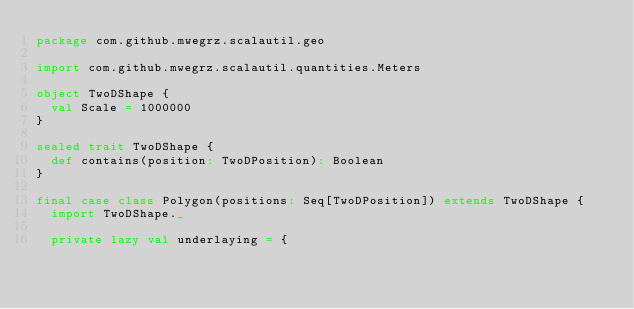Convert code to text. <code><loc_0><loc_0><loc_500><loc_500><_Scala_>package com.github.mwegrz.scalautil.geo

import com.github.mwegrz.scalautil.quantities.Meters

object TwoDShape {
  val Scale = 1000000
}

sealed trait TwoDShape {
  def contains(position: TwoDPosition): Boolean
}

final case class Polygon(positions: Seq[TwoDPosition]) extends TwoDShape {
  import TwoDShape._

  private lazy val underlaying = {</code> 